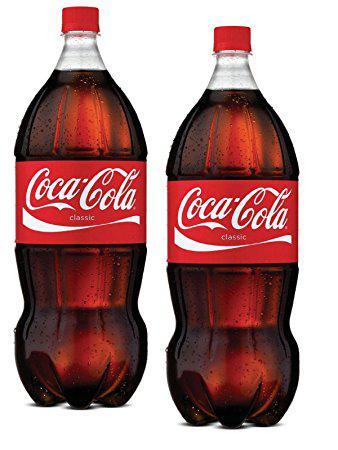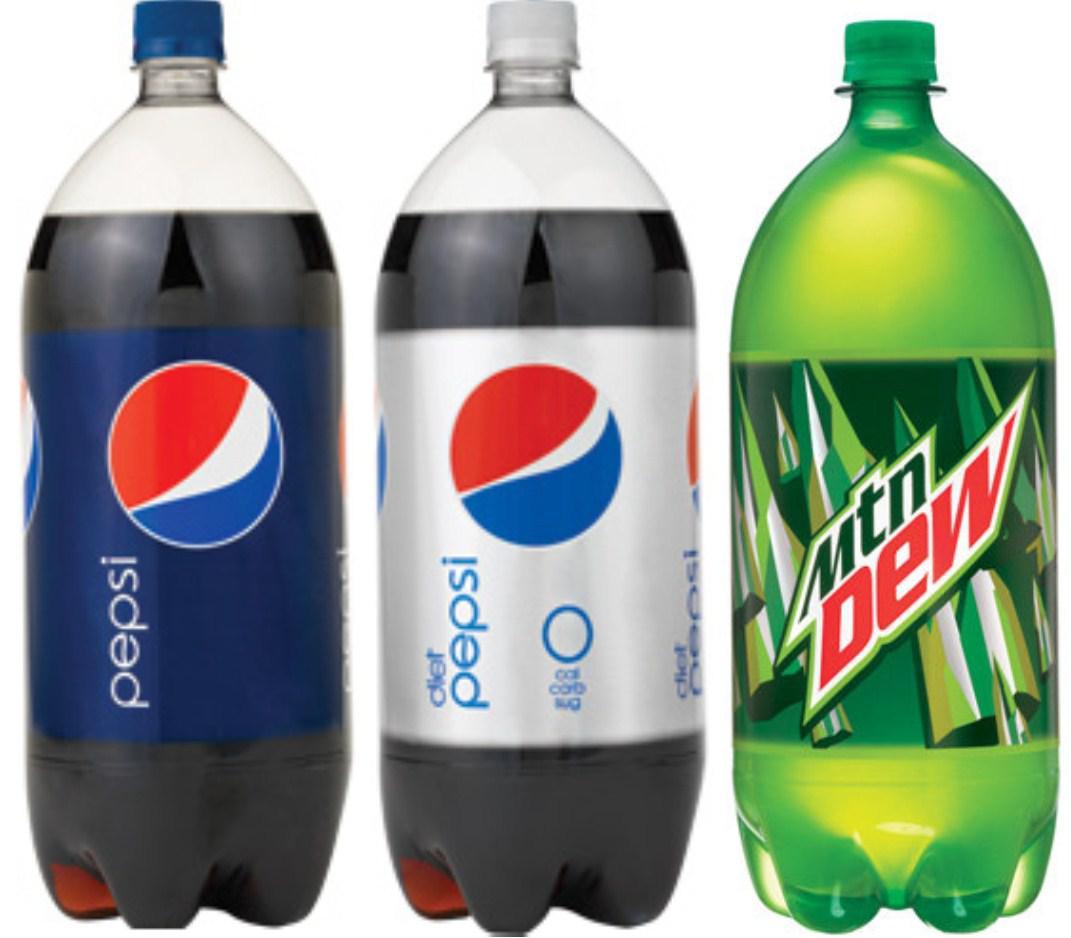The first image is the image on the left, the second image is the image on the right. Analyze the images presented: Is the assertion "The left image contains two non-overlapping bottles, and the right image contains three non-overlapping bottles." valid? Answer yes or no. Yes. The first image is the image on the left, the second image is the image on the right. Examine the images to the left and right. Is the description "There are five soda bottles in total." accurate? Answer yes or no. Yes. 